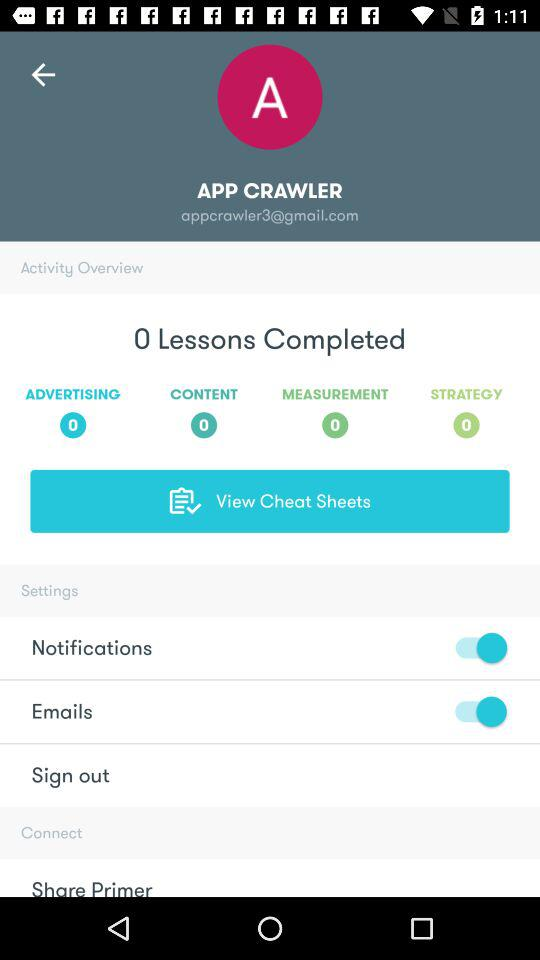How many lessons are completed?
Answer the question using a single word or phrase. 0 